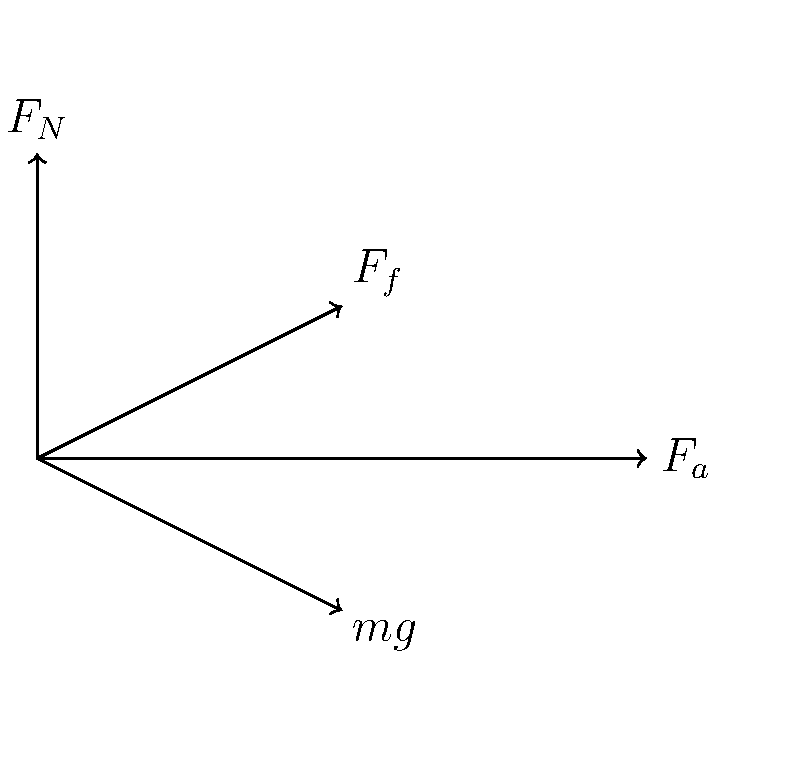In the force diagram of a sprinter at the starting blocks, which force is crucial for propelling the athlete forward and is directly related to the coefficient of friction between the blocks and the track? To answer this question, let's analyze the forces acting on the sprinter at the starting blocks:

1. $F_N$: Normal force - perpendicular to the ground, supporting the sprinter's weight.
2. $F_f$: Friction force - parallel to the ground, opposing motion.
3. $F_a$: Applied force - the force the sprinter exerts on the blocks.
4. $mg$: Gravitational force - pulling the sprinter downward.

The key force for propelling the sprinter forward is the friction force ($F_f$). This is because:

1. The sprinter pushes back against the starting blocks (applied force $F_a$).
2. According to Newton's Third Law, the blocks exert an equal and opposite force on the sprinter.
3. This reaction force has two components: the normal force ($F_N$) and the friction force ($F_f$).
4. The friction force is parallel to the ground and points forward, propelling the sprinter.
5. The magnitude of the friction force is directly related to the coefficient of friction ($\mu$) between the blocks and the track: $F_f = \mu F_N$.

A higher coefficient of friction allows for a greater friction force, enabling the sprinter to push off more effectively and accelerate faster.
Answer: Friction force ($F_f$) 